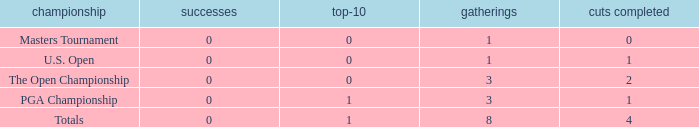Write the full table. {'header': ['championship', 'successes', 'top-10', 'gatherings', 'cuts completed'], 'rows': [['Masters Tournament', '0', '0', '1', '0'], ['U.S. Open', '0', '0', '1', '1'], ['The Open Championship', '0', '0', '3', '2'], ['PGA Championship', '0', '1', '3', '1'], ['Totals', '0', '1', '8', '4']]} For majors with 8 events played and more than 1 made cut, what is the most top-10s recorded? 1.0. 